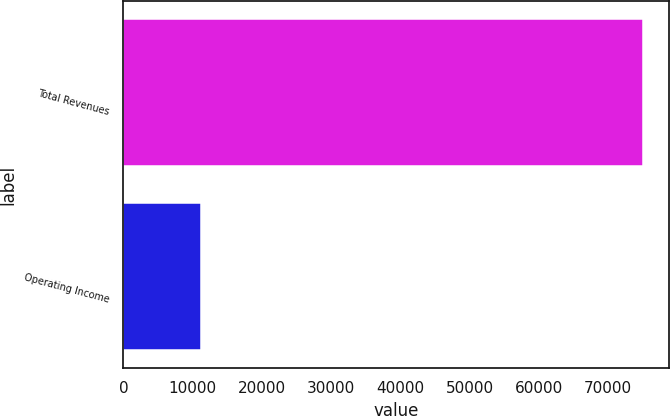Convert chart. <chart><loc_0><loc_0><loc_500><loc_500><bar_chart><fcel>Total Revenues<fcel>Operating Income<nl><fcel>74957<fcel>11175<nl></chart> 